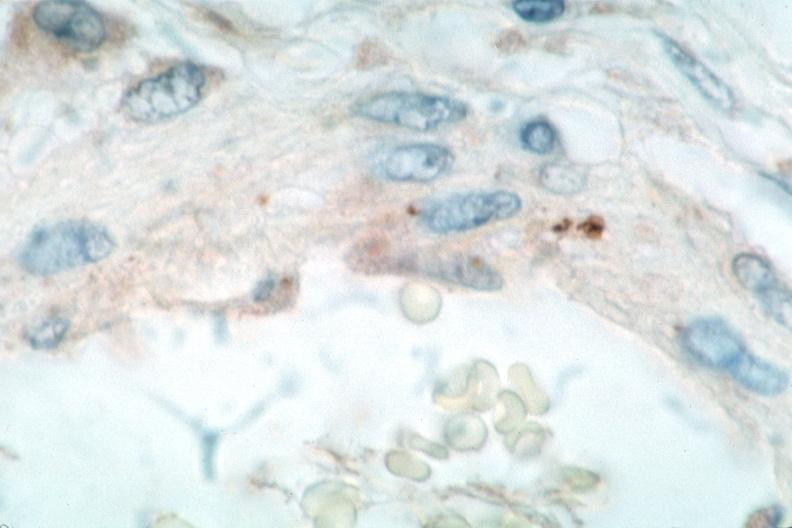what spotted fever , immunoperoxidase staining vessels for rickettsia rickettsii?
Answer the question using a single word or phrase. Vasculitis rocky mountain 